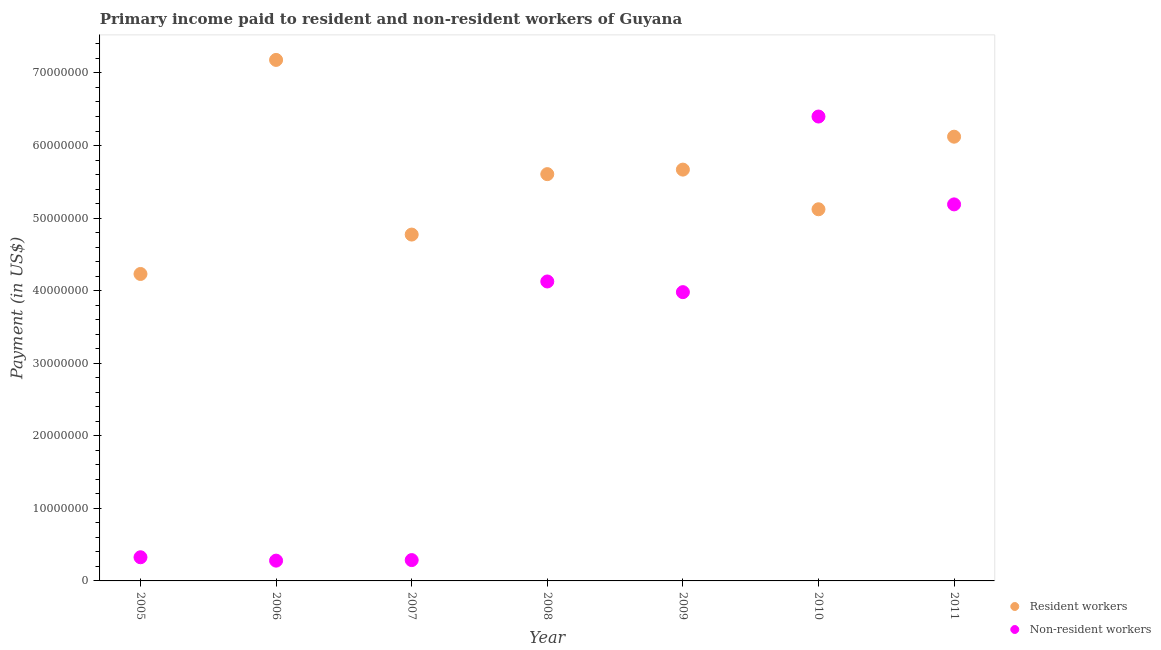How many different coloured dotlines are there?
Give a very brief answer. 2. What is the payment made to resident workers in 2005?
Your response must be concise. 4.23e+07. Across all years, what is the maximum payment made to resident workers?
Your answer should be compact. 7.18e+07. Across all years, what is the minimum payment made to non-resident workers?
Offer a terse response. 2.80e+06. In which year was the payment made to resident workers maximum?
Your response must be concise. 2006. What is the total payment made to resident workers in the graph?
Ensure brevity in your answer.  3.87e+08. What is the difference between the payment made to non-resident workers in 2007 and that in 2008?
Give a very brief answer. -3.84e+07. What is the difference between the payment made to resident workers in 2011 and the payment made to non-resident workers in 2010?
Your response must be concise. -2.78e+06. What is the average payment made to resident workers per year?
Offer a terse response. 5.53e+07. In the year 2009, what is the difference between the payment made to resident workers and payment made to non-resident workers?
Provide a succinct answer. 1.69e+07. In how many years, is the payment made to resident workers greater than 4000000 US$?
Your answer should be compact. 7. What is the ratio of the payment made to resident workers in 2005 to that in 2010?
Your answer should be compact. 0.83. What is the difference between the highest and the second highest payment made to resident workers?
Your answer should be very brief. 1.06e+07. What is the difference between the highest and the lowest payment made to non-resident workers?
Offer a terse response. 6.12e+07. In how many years, is the payment made to non-resident workers greater than the average payment made to non-resident workers taken over all years?
Your response must be concise. 4. Is the payment made to resident workers strictly greater than the payment made to non-resident workers over the years?
Your response must be concise. No. Is the payment made to resident workers strictly less than the payment made to non-resident workers over the years?
Provide a short and direct response. No. How many dotlines are there?
Your response must be concise. 2. Are the values on the major ticks of Y-axis written in scientific E-notation?
Offer a very short reply. No. Does the graph contain any zero values?
Provide a succinct answer. No. Where does the legend appear in the graph?
Provide a short and direct response. Bottom right. How many legend labels are there?
Ensure brevity in your answer.  2. What is the title of the graph?
Provide a succinct answer. Primary income paid to resident and non-resident workers of Guyana. Does "Female population" appear as one of the legend labels in the graph?
Your answer should be compact. No. What is the label or title of the X-axis?
Offer a very short reply. Year. What is the label or title of the Y-axis?
Give a very brief answer. Payment (in US$). What is the Payment (in US$) in Resident workers in 2005?
Give a very brief answer. 4.23e+07. What is the Payment (in US$) of Non-resident workers in 2005?
Give a very brief answer. 3.26e+06. What is the Payment (in US$) in Resident workers in 2006?
Make the answer very short. 7.18e+07. What is the Payment (in US$) in Non-resident workers in 2006?
Your answer should be compact. 2.80e+06. What is the Payment (in US$) of Resident workers in 2007?
Your response must be concise. 4.77e+07. What is the Payment (in US$) of Non-resident workers in 2007?
Your answer should be very brief. 2.87e+06. What is the Payment (in US$) in Resident workers in 2008?
Provide a short and direct response. 5.61e+07. What is the Payment (in US$) of Non-resident workers in 2008?
Provide a succinct answer. 4.13e+07. What is the Payment (in US$) in Resident workers in 2009?
Offer a very short reply. 5.67e+07. What is the Payment (in US$) in Non-resident workers in 2009?
Offer a terse response. 3.98e+07. What is the Payment (in US$) of Resident workers in 2010?
Provide a succinct answer. 5.12e+07. What is the Payment (in US$) of Non-resident workers in 2010?
Your answer should be compact. 6.40e+07. What is the Payment (in US$) in Resident workers in 2011?
Offer a terse response. 6.12e+07. What is the Payment (in US$) in Non-resident workers in 2011?
Give a very brief answer. 5.19e+07. Across all years, what is the maximum Payment (in US$) of Resident workers?
Offer a terse response. 7.18e+07. Across all years, what is the maximum Payment (in US$) of Non-resident workers?
Your response must be concise. 6.40e+07. Across all years, what is the minimum Payment (in US$) in Resident workers?
Offer a very short reply. 4.23e+07. Across all years, what is the minimum Payment (in US$) of Non-resident workers?
Ensure brevity in your answer.  2.80e+06. What is the total Payment (in US$) of Resident workers in the graph?
Provide a succinct answer. 3.87e+08. What is the total Payment (in US$) in Non-resident workers in the graph?
Ensure brevity in your answer.  2.06e+08. What is the difference between the Payment (in US$) in Resident workers in 2005 and that in 2006?
Provide a succinct answer. -2.95e+07. What is the difference between the Payment (in US$) in Non-resident workers in 2005 and that in 2006?
Offer a very short reply. 4.65e+05. What is the difference between the Payment (in US$) in Resident workers in 2005 and that in 2007?
Provide a succinct answer. -5.43e+06. What is the difference between the Payment (in US$) of Non-resident workers in 2005 and that in 2007?
Offer a very short reply. 3.89e+05. What is the difference between the Payment (in US$) in Resident workers in 2005 and that in 2008?
Provide a succinct answer. -1.38e+07. What is the difference between the Payment (in US$) of Non-resident workers in 2005 and that in 2008?
Keep it short and to the point. -3.80e+07. What is the difference between the Payment (in US$) in Resident workers in 2005 and that in 2009?
Keep it short and to the point. -1.44e+07. What is the difference between the Payment (in US$) in Non-resident workers in 2005 and that in 2009?
Your response must be concise. -3.65e+07. What is the difference between the Payment (in US$) in Resident workers in 2005 and that in 2010?
Your answer should be compact. -8.92e+06. What is the difference between the Payment (in US$) in Non-resident workers in 2005 and that in 2010?
Give a very brief answer. -6.07e+07. What is the difference between the Payment (in US$) in Resident workers in 2005 and that in 2011?
Give a very brief answer. -1.89e+07. What is the difference between the Payment (in US$) of Non-resident workers in 2005 and that in 2011?
Your answer should be compact. -4.86e+07. What is the difference between the Payment (in US$) of Resident workers in 2006 and that in 2007?
Provide a short and direct response. 2.41e+07. What is the difference between the Payment (in US$) of Non-resident workers in 2006 and that in 2007?
Provide a succinct answer. -7.60e+04. What is the difference between the Payment (in US$) of Resident workers in 2006 and that in 2008?
Keep it short and to the point. 1.57e+07. What is the difference between the Payment (in US$) in Non-resident workers in 2006 and that in 2008?
Keep it short and to the point. -3.85e+07. What is the difference between the Payment (in US$) of Resident workers in 2006 and that in 2009?
Provide a short and direct response. 1.51e+07. What is the difference between the Payment (in US$) of Non-resident workers in 2006 and that in 2009?
Ensure brevity in your answer.  -3.70e+07. What is the difference between the Payment (in US$) of Resident workers in 2006 and that in 2010?
Provide a short and direct response. 2.06e+07. What is the difference between the Payment (in US$) of Non-resident workers in 2006 and that in 2010?
Give a very brief answer. -6.12e+07. What is the difference between the Payment (in US$) in Resident workers in 2006 and that in 2011?
Ensure brevity in your answer.  1.06e+07. What is the difference between the Payment (in US$) in Non-resident workers in 2006 and that in 2011?
Make the answer very short. -4.91e+07. What is the difference between the Payment (in US$) in Resident workers in 2007 and that in 2008?
Ensure brevity in your answer.  -8.33e+06. What is the difference between the Payment (in US$) in Non-resident workers in 2007 and that in 2008?
Give a very brief answer. -3.84e+07. What is the difference between the Payment (in US$) of Resident workers in 2007 and that in 2009?
Your response must be concise. -8.95e+06. What is the difference between the Payment (in US$) of Non-resident workers in 2007 and that in 2009?
Provide a succinct answer. -3.69e+07. What is the difference between the Payment (in US$) in Resident workers in 2007 and that in 2010?
Keep it short and to the point. -3.49e+06. What is the difference between the Payment (in US$) of Non-resident workers in 2007 and that in 2010?
Ensure brevity in your answer.  -6.11e+07. What is the difference between the Payment (in US$) of Resident workers in 2007 and that in 2011?
Provide a short and direct response. -1.35e+07. What is the difference between the Payment (in US$) of Non-resident workers in 2007 and that in 2011?
Your answer should be very brief. -4.90e+07. What is the difference between the Payment (in US$) of Resident workers in 2008 and that in 2009?
Provide a succinct answer. -6.24e+05. What is the difference between the Payment (in US$) in Non-resident workers in 2008 and that in 2009?
Keep it short and to the point. 1.47e+06. What is the difference between the Payment (in US$) of Resident workers in 2008 and that in 2010?
Your answer should be compact. 4.84e+06. What is the difference between the Payment (in US$) in Non-resident workers in 2008 and that in 2010?
Offer a very short reply. -2.27e+07. What is the difference between the Payment (in US$) in Resident workers in 2008 and that in 2011?
Offer a terse response. -5.16e+06. What is the difference between the Payment (in US$) of Non-resident workers in 2008 and that in 2011?
Provide a short and direct response. -1.06e+07. What is the difference between the Payment (in US$) in Resident workers in 2009 and that in 2010?
Your response must be concise. 5.47e+06. What is the difference between the Payment (in US$) of Non-resident workers in 2009 and that in 2010?
Make the answer very short. -2.42e+07. What is the difference between the Payment (in US$) of Resident workers in 2009 and that in 2011?
Your answer should be compact. -4.54e+06. What is the difference between the Payment (in US$) of Non-resident workers in 2009 and that in 2011?
Give a very brief answer. -1.21e+07. What is the difference between the Payment (in US$) of Resident workers in 2010 and that in 2011?
Offer a terse response. -1.00e+07. What is the difference between the Payment (in US$) of Non-resident workers in 2010 and that in 2011?
Your response must be concise. 1.21e+07. What is the difference between the Payment (in US$) of Resident workers in 2005 and the Payment (in US$) of Non-resident workers in 2006?
Your answer should be compact. 3.95e+07. What is the difference between the Payment (in US$) of Resident workers in 2005 and the Payment (in US$) of Non-resident workers in 2007?
Provide a short and direct response. 3.94e+07. What is the difference between the Payment (in US$) of Resident workers in 2005 and the Payment (in US$) of Non-resident workers in 2008?
Give a very brief answer. 1.03e+06. What is the difference between the Payment (in US$) of Resident workers in 2005 and the Payment (in US$) of Non-resident workers in 2009?
Offer a terse response. 2.50e+06. What is the difference between the Payment (in US$) of Resident workers in 2005 and the Payment (in US$) of Non-resident workers in 2010?
Your answer should be very brief. -2.17e+07. What is the difference between the Payment (in US$) of Resident workers in 2005 and the Payment (in US$) of Non-resident workers in 2011?
Ensure brevity in your answer.  -9.59e+06. What is the difference between the Payment (in US$) of Resident workers in 2006 and the Payment (in US$) of Non-resident workers in 2007?
Make the answer very short. 6.89e+07. What is the difference between the Payment (in US$) of Resident workers in 2006 and the Payment (in US$) of Non-resident workers in 2008?
Offer a terse response. 3.05e+07. What is the difference between the Payment (in US$) of Resident workers in 2006 and the Payment (in US$) of Non-resident workers in 2009?
Ensure brevity in your answer.  3.20e+07. What is the difference between the Payment (in US$) in Resident workers in 2006 and the Payment (in US$) in Non-resident workers in 2010?
Keep it short and to the point. 7.80e+06. What is the difference between the Payment (in US$) of Resident workers in 2006 and the Payment (in US$) of Non-resident workers in 2011?
Your answer should be very brief. 1.99e+07. What is the difference between the Payment (in US$) of Resident workers in 2007 and the Payment (in US$) of Non-resident workers in 2008?
Ensure brevity in your answer.  6.46e+06. What is the difference between the Payment (in US$) in Resident workers in 2007 and the Payment (in US$) in Non-resident workers in 2009?
Offer a very short reply. 7.93e+06. What is the difference between the Payment (in US$) in Resident workers in 2007 and the Payment (in US$) in Non-resident workers in 2010?
Give a very brief answer. -1.63e+07. What is the difference between the Payment (in US$) of Resident workers in 2007 and the Payment (in US$) of Non-resident workers in 2011?
Provide a short and direct response. -4.16e+06. What is the difference between the Payment (in US$) of Resident workers in 2008 and the Payment (in US$) of Non-resident workers in 2009?
Offer a terse response. 1.63e+07. What is the difference between the Payment (in US$) of Resident workers in 2008 and the Payment (in US$) of Non-resident workers in 2010?
Make the answer very short. -7.94e+06. What is the difference between the Payment (in US$) in Resident workers in 2008 and the Payment (in US$) in Non-resident workers in 2011?
Your answer should be compact. 4.17e+06. What is the difference between the Payment (in US$) in Resident workers in 2009 and the Payment (in US$) in Non-resident workers in 2010?
Make the answer very short. -7.31e+06. What is the difference between the Payment (in US$) in Resident workers in 2009 and the Payment (in US$) in Non-resident workers in 2011?
Offer a terse response. 4.79e+06. What is the difference between the Payment (in US$) of Resident workers in 2010 and the Payment (in US$) of Non-resident workers in 2011?
Your answer should be very brief. -6.73e+05. What is the average Payment (in US$) in Resident workers per year?
Give a very brief answer. 5.53e+07. What is the average Payment (in US$) of Non-resident workers per year?
Keep it short and to the point. 2.94e+07. In the year 2005, what is the difference between the Payment (in US$) in Resident workers and Payment (in US$) in Non-resident workers?
Provide a short and direct response. 3.90e+07. In the year 2006, what is the difference between the Payment (in US$) of Resident workers and Payment (in US$) of Non-resident workers?
Your response must be concise. 6.90e+07. In the year 2007, what is the difference between the Payment (in US$) of Resident workers and Payment (in US$) of Non-resident workers?
Your answer should be very brief. 4.49e+07. In the year 2008, what is the difference between the Payment (in US$) in Resident workers and Payment (in US$) in Non-resident workers?
Your response must be concise. 1.48e+07. In the year 2009, what is the difference between the Payment (in US$) in Resident workers and Payment (in US$) in Non-resident workers?
Make the answer very short. 1.69e+07. In the year 2010, what is the difference between the Payment (in US$) of Resident workers and Payment (in US$) of Non-resident workers?
Make the answer very short. -1.28e+07. In the year 2011, what is the difference between the Payment (in US$) in Resident workers and Payment (in US$) in Non-resident workers?
Offer a very short reply. 9.33e+06. What is the ratio of the Payment (in US$) in Resident workers in 2005 to that in 2006?
Provide a short and direct response. 0.59. What is the ratio of the Payment (in US$) of Non-resident workers in 2005 to that in 2006?
Your answer should be very brief. 1.17. What is the ratio of the Payment (in US$) of Resident workers in 2005 to that in 2007?
Provide a succinct answer. 0.89. What is the ratio of the Payment (in US$) of Non-resident workers in 2005 to that in 2007?
Offer a very short reply. 1.14. What is the ratio of the Payment (in US$) of Resident workers in 2005 to that in 2008?
Make the answer very short. 0.75. What is the ratio of the Payment (in US$) of Non-resident workers in 2005 to that in 2008?
Your answer should be compact. 0.08. What is the ratio of the Payment (in US$) of Resident workers in 2005 to that in 2009?
Keep it short and to the point. 0.75. What is the ratio of the Payment (in US$) of Non-resident workers in 2005 to that in 2009?
Your answer should be very brief. 0.08. What is the ratio of the Payment (in US$) of Resident workers in 2005 to that in 2010?
Give a very brief answer. 0.83. What is the ratio of the Payment (in US$) of Non-resident workers in 2005 to that in 2010?
Your response must be concise. 0.05. What is the ratio of the Payment (in US$) in Resident workers in 2005 to that in 2011?
Give a very brief answer. 0.69. What is the ratio of the Payment (in US$) of Non-resident workers in 2005 to that in 2011?
Ensure brevity in your answer.  0.06. What is the ratio of the Payment (in US$) of Resident workers in 2006 to that in 2007?
Provide a succinct answer. 1.5. What is the ratio of the Payment (in US$) of Non-resident workers in 2006 to that in 2007?
Your answer should be compact. 0.97. What is the ratio of the Payment (in US$) in Resident workers in 2006 to that in 2008?
Give a very brief answer. 1.28. What is the ratio of the Payment (in US$) in Non-resident workers in 2006 to that in 2008?
Provide a succinct answer. 0.07. What is the ratio of the Payment (in US$) of Resident workers in 2006 to that in 2009?
Provide a short and direct response. 1.27. What is the ratio of the Payment (in US$) in Non-resident workers in 2006 to that in 2009?
Your answer should be compact. 0.07. What is the ratio of the Payment (in US$) of Resident workers in 2006 to that in 2010?
Offer a terse response. 1.4. What is the ratio of the Payment (in US$) of Non-resident workers in 2006 to that in 2010?
Your answer should be very brief. 0.04. What is the ratio of the Payment (in US$) in Resident workers in 2006 to that in 2011?
Give a very brief answer. 1.17. What is the ratio of the Payment (in US$) in Non-resident workers in 2006 to that in 2011?
Make the answer very short. 0.05. What is the ratio of the Payment (in US$) in Resident workers in 2007 to that in 2008?
Give a very brief answer. 0.85. What is the ratio of the Payment (in US$) of Non-resident workers in 2007 to that in 2008?
Your response must be concise. 0.07. What is the ratio of the Payment (in US$) of Resident workers in 2007 to that in 2009?
Keep it short and to the point. 0.84. What is the ratio of the Payment (in US$) in Non-resident workers in 2007 to that in 2009?
Provide a short and direct response. 0.07. What is the ratio of the Payment (in US$) of Resident workers in 2007 to that in 2010?
Give a very brief answer. 0.93. What is the ratio of the Payment (in US$) of Non-resident workers in 2007 to that in 2010?
Provide a succinct answer. 0.04. What is the ratio of the Payment (in US$) of Resident workers in 2007 to that in 2011?
Offer a terse response. 0.78. What is the ratio of the Payment (in US$) of Non-resident workers in 2007 to that in 2011?
Your answer should be very brief. 0.06. What is the ratio of the Payment (in US$) in Resident workers in 2008 to that in 2009?
Keep it short and to the point. 0.99. What is the ratio of the Payment (in US$) in Non-resident workers in 2008 to that in 2009?
Make the answer very short. 1.04. What is the ratio of the Payment (in US$) in Resident workers in 2008 to that in 2010?
Offer a very short reply. 1.09. What is the ratio of the Payment (in US$) in Non-resident workers in 2008 to that in 2010?
Provide a short and direct response. 0.64. What is the ratio of the Payment (in US$) in Resident workers in 2008 to that in 2011?
Your response must be concise. 0.92. What is the ratio of the Payment (in US$) in Non-resident workers in 2008 to that in 2011?
Offer a terse response. 0.8. What is the ratio of the Payment (in US$) of Resident workers in 2009 to that in 2010?
Provide a short and direct response. 1.11. What is the ratio of the Payment (in US$) of Non-resident workers in 2009 to that in 2010?
Your answer should be compact. 0.62. What is the ratio of the Payment (in US$) in Resident workers in 2009 to that in 2011?
Give a very brief answer. 0.93. What is the ratio of the Payment (in US$) in Non-resident workers in 2009 to that in 2011?
Offer a terse response. 0.77. What is the ratio of the Payment (in US$) of Resident workers in 2010 to that in 2011?
Offer a terse response. 0.84. What is the ratio of the Payment (in US$) in Non-resident workers in 2010 to that in 2011?
Provide a short and direct response. 1.23. What is the difference between the highest and the second highest Payment (in US$) of Resident workers?
Provide a succinct answer. 1.06e+07. What is the difference between the highest and the second highest Payment (in US$) of Non-resident workers?
Your response must be concise. 1.21e+07. What is the difference between the highest and the lowest Payment (in US$) in Resident workers?
Keep it short and to the point. 2.95e+07. What is the difference between the highest and the lowest Payment (in US$) in Non-resident workers?
Make the answer very short. 6.12e+07. 